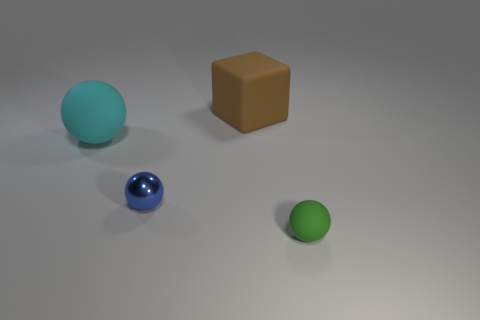Add 1 blue metal spheres. How many objects exist? 5 Subtract all cubes. How many objects are left? 3 Add 3 blue balls. How many blue balls exist? 4 Subtract 0 red blocks. How many objects are left? 4 Subtract all small blocks. Subtract all brown matte things. How many objects are left? 3 Add 1 blue shiny things. How many blue shiny things are left? 2 